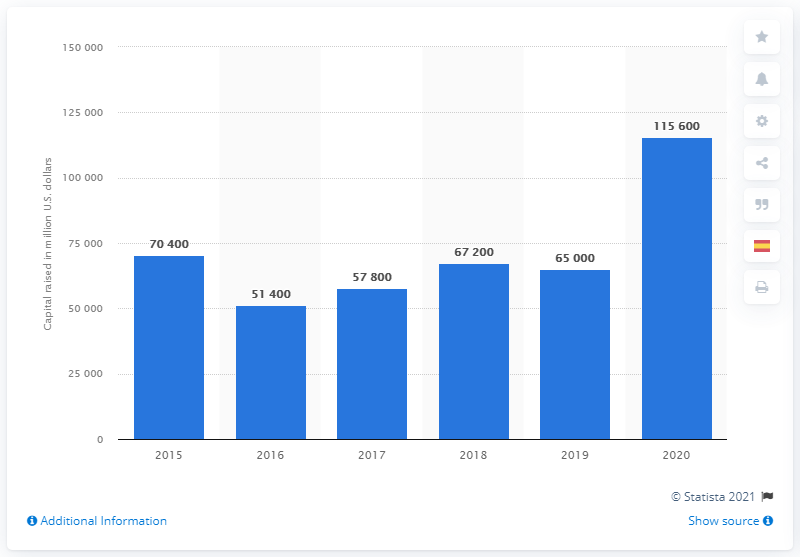List a handful of essential elements in this visual. In 2020, the biotech industry in the U.S. and Europe raised a total of approximately 115,600 in capital. 